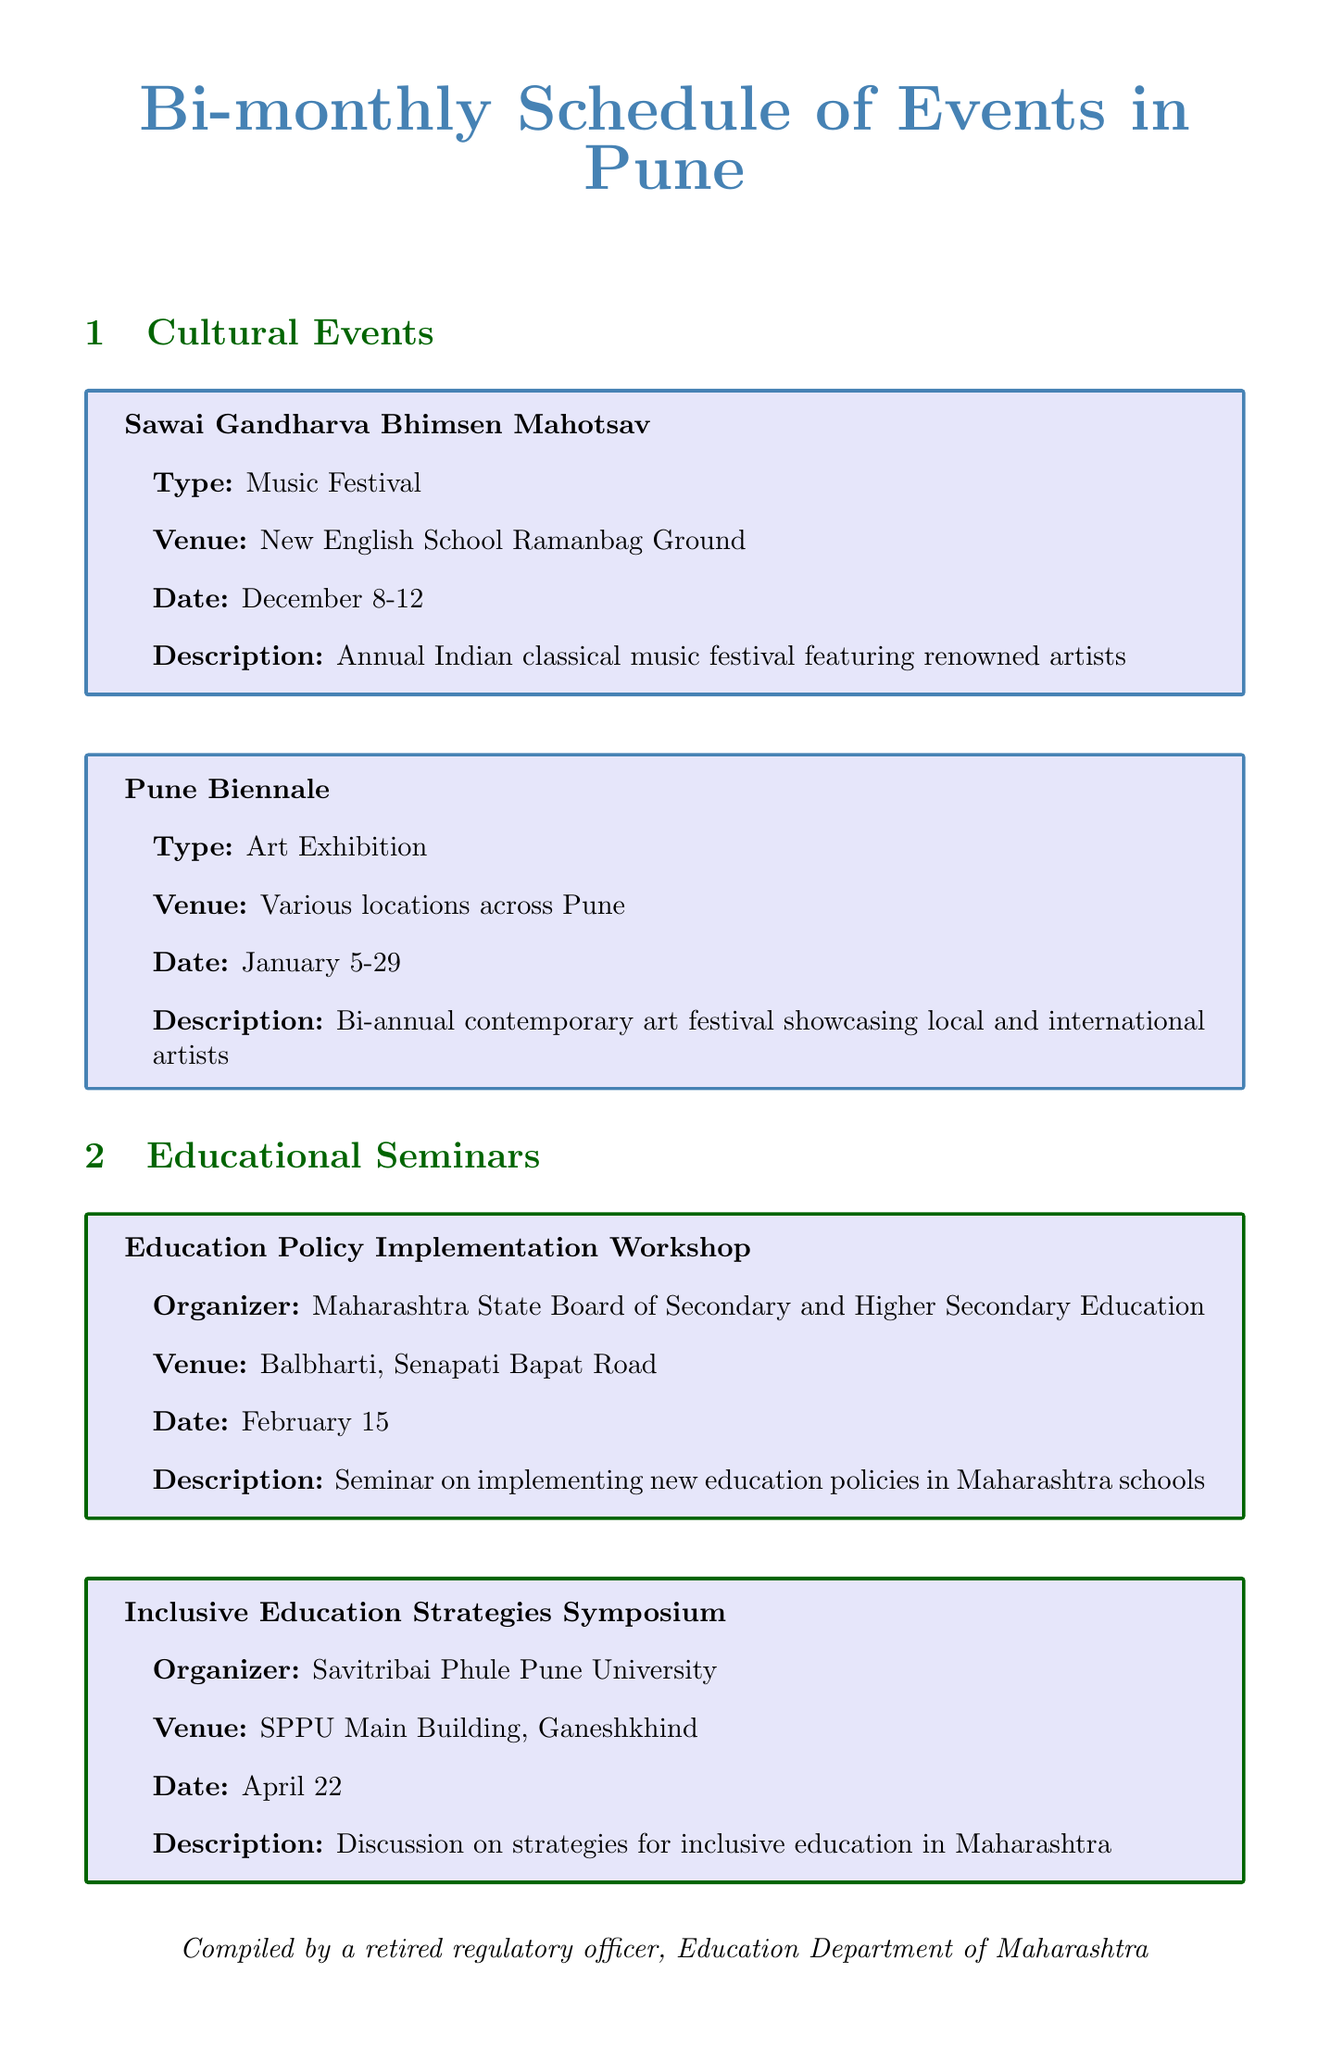What is the date for the Sawai Gandharva Bhimsen Mahotsav? The date of the event is specified in the schedule as December 8-12.
Answer: December 8-12 Who is organizing the Digital Transformation in Education Conference? The organizer is listed in the document as Maharashtra Knowledge Corporation Limited (MKCL).
Answer: Maharashtra Knowledge Corporation Limited (MKCL) What is the venue for the Inclusive Education Strategies Symposium? The venue is provided in the document as SPPU Main Building, Ganeshkhind.
Answer: SPPU Main Building, Ganeshkhind What type of event is the Pune Festival? The document describes the Pune Festival as a Cultural Festival.
Answer: Cultural Festival On what date is the Education Regulation Update Session scheduled? The date is outlined in the schedule as May 20.
Answer: May 20 Which cultural event takes place in January? The only cultural event mentioned in January is the Pune Biennale, which is detailed in the document.
Answer: Pune Biennale How frequently does the Lifelong Learning Lecture Series occur? The schedule lists this program as occurring every second Saturday, indicating its frequency.
Answer: Every second Saturday What is the purpose of the Teacher Training and Development Workshop? The description of the workshop provides insight that it focuses on enhancing teaching skills and methodologies.
Answer: Enhancing teaching skills and methodologies 